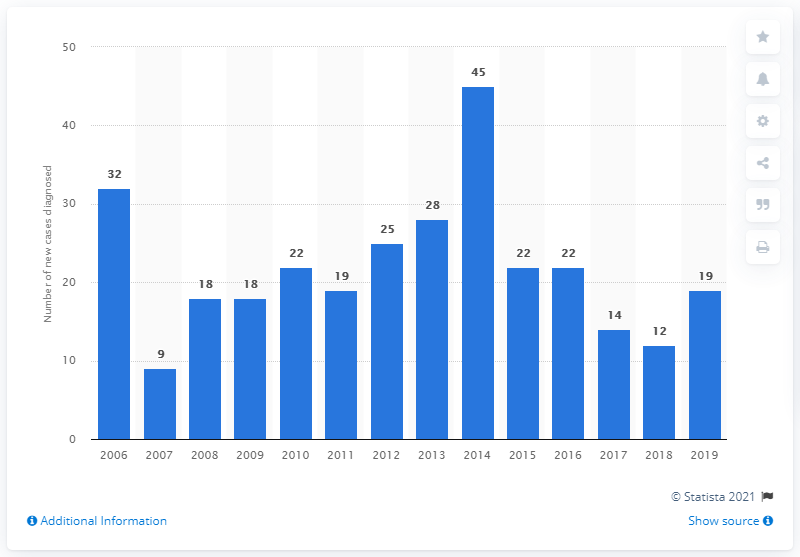Give some essential details in this illustration. In 2014, a total of 45 new cases of AIDS were diagnosed in Norway. In 2015, a total of 19 new cases of AIDS were diagnosed in Norway. In 2015, there was a significant decrease in the number of new cases of AIDS in Norway. 